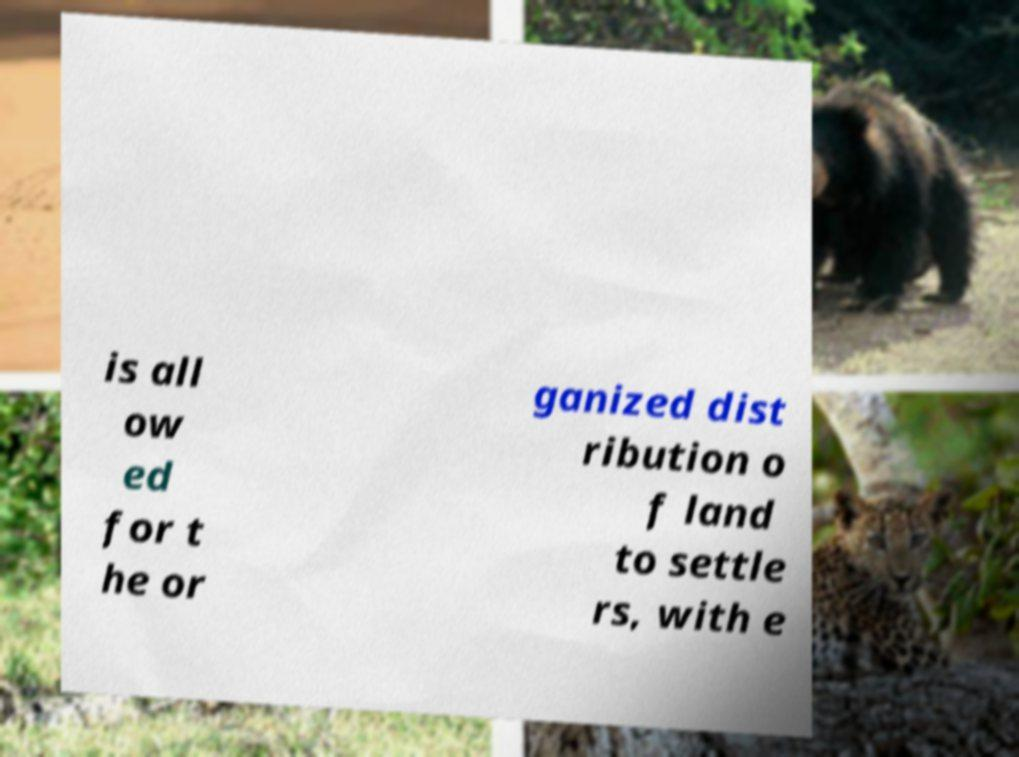Could you extract and type out the text from this image? is all ow ed for t he or ganized dist ribution o f land to settle rs, with e 